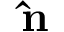Convert formula to latex. <formula><loc_0><loc_0><loc_500><loc_500>\hat { n } \,</formula> 